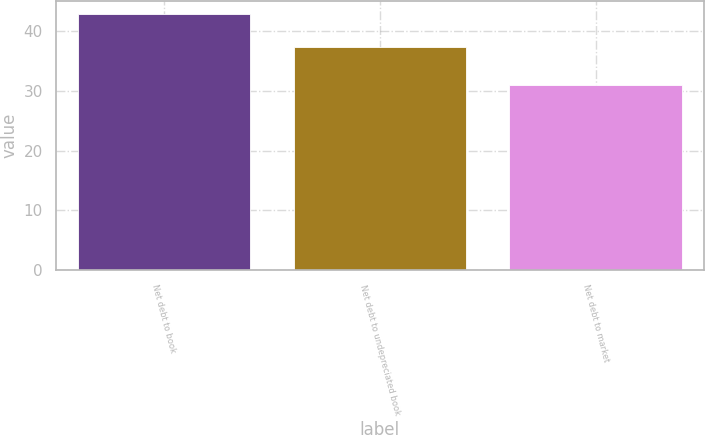Convert chart to OTSL. <chart><loc_0><loc_0><loc_500><loc_500><bar_chart><fcel>Net debt to book<fcel>Net debt to undepreciated book<fcel>Net debt to market<nl><fcel>42.9<fcel>37.4<fcel>31.1<nl></chart> 